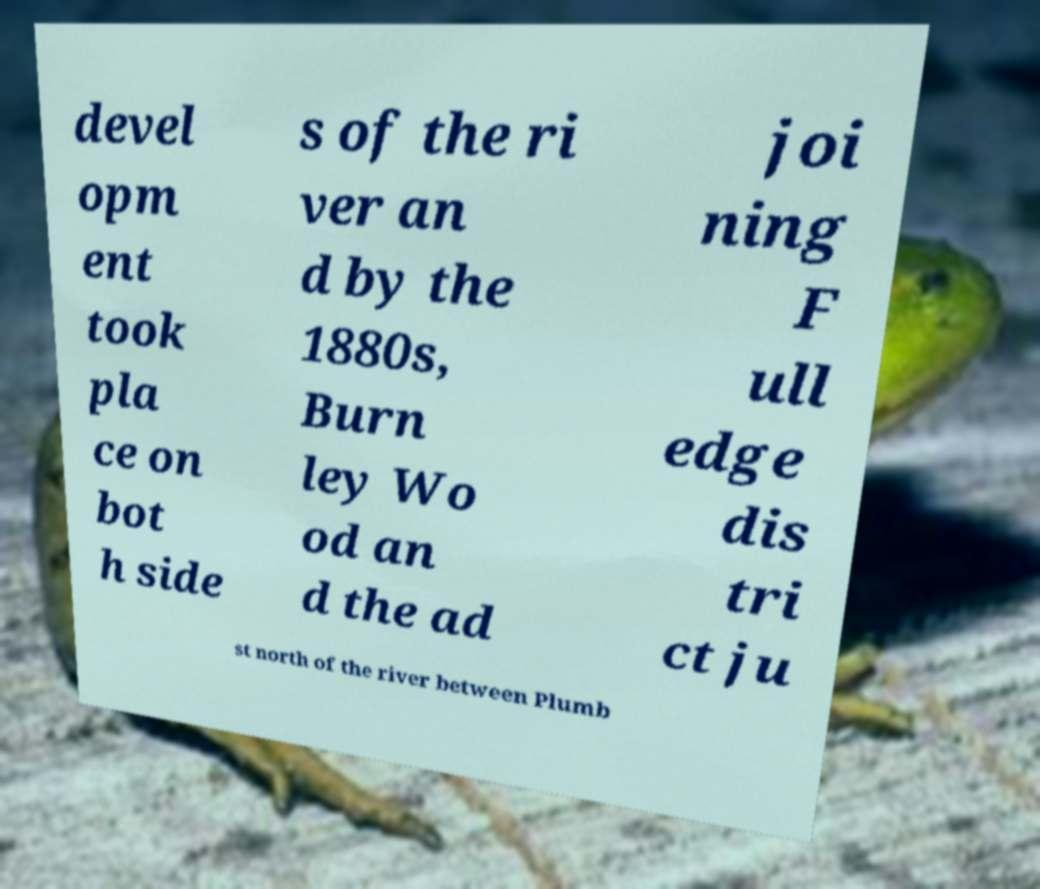What messages or text are displayed in this image? I need them in a readable, typed format. devel opm ent took pla ce on bot h side s of the ri ver an d by the 1880s, Burn ley Wo od an d the ad joi ning F ull edge dis tri ct ju st north of the river between Plumb 